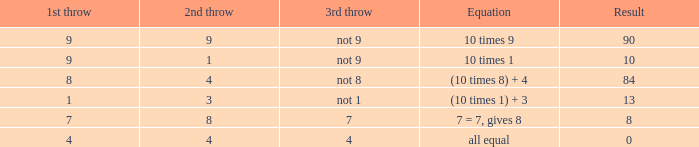Assuming the equation is equal on both sides, what is the result of the third throw? 4.0. 